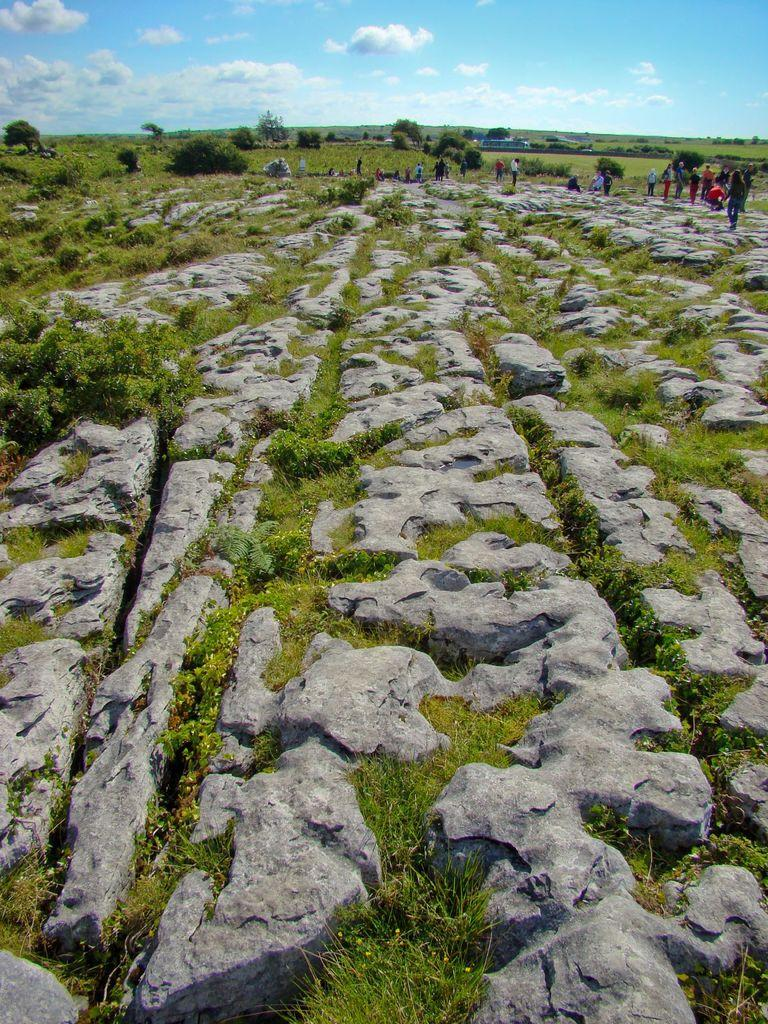What type of natural elements can be seen in the image? There are stones, grass, plants, and trees in the image. Are there any living beings present in the image? Yes, there are people in the image. What is the color of the sky in the image? The sky has a combination of white and blue colors in the image. What type of bread can be seen in the hands of the people in the image? There is no bread present in the image; the people are not holding any food items. How many dogs are visible in the image? There are no dogs present in the image. 